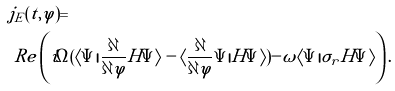Convert formula to latex. <formula><loc_0><loc_0><loc_500><loc_500>& j _ { E } ( t , \varphi ) = \\ & \ R e \left ( i \Omega ( \langle \Psi | \frac { \partial } { \partial \varphi } H \Psi \rangle - \langle \frac { \partial } { \partial \varphi } \Psi | H \Psi \rangle ) - \omega \langle \Psi | \sigma _ { r } H \Psi \rangle \right ) .</formula> 